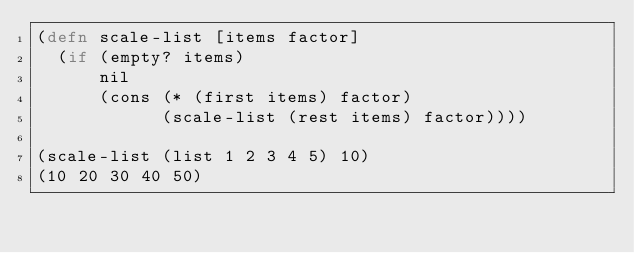Convert code to text. <code><loc_0><loc_0><loc_500><loc_500><_Clojure_>(defn scale-list [items factor]  
  (if (empty? items)  
      nil  
      (cons (* (first items) factor)  
            (scale-list (rest items) factor))))  

(scale-list (list 1 2 3 4 5) 10)  
(10 20 30 40 50)
</code> 